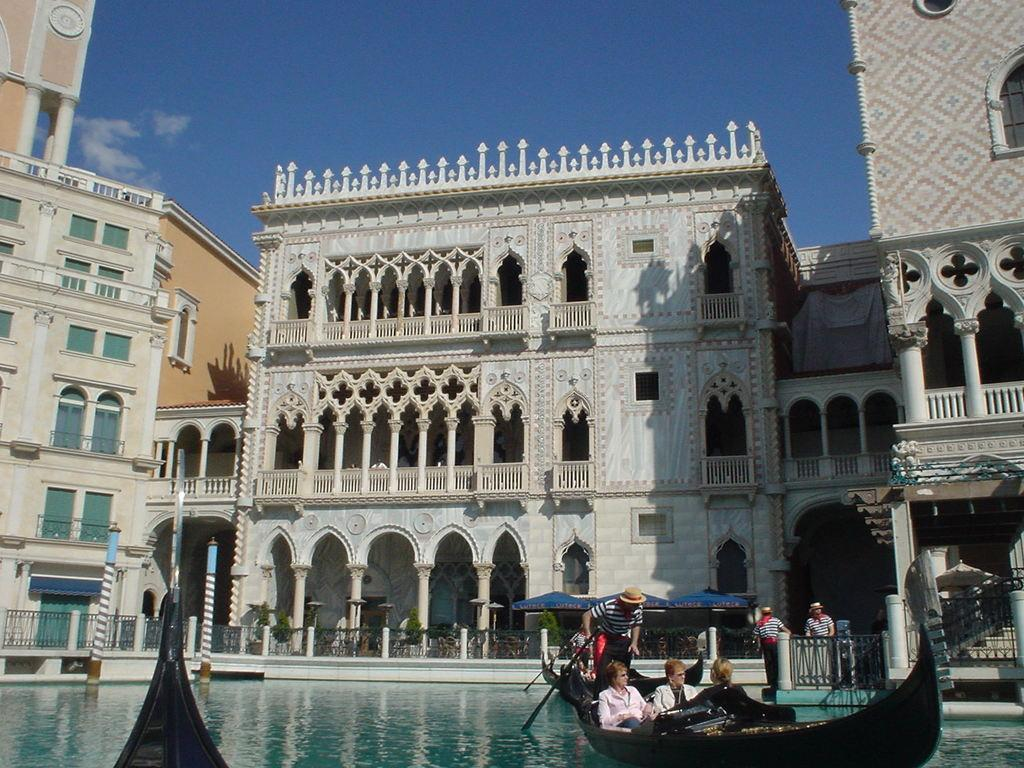How many people are on the boat in the image? There are four persons riding the boat in the image. What is the boat on in the image? The boat is on water in the image. What can be seen in the background of the image? There are buildings, a fence, plants, pillars, and the sky visible in the background. What type of mask is being worn by the person in the front of the boat? There is no person wearing a mask in the image. 